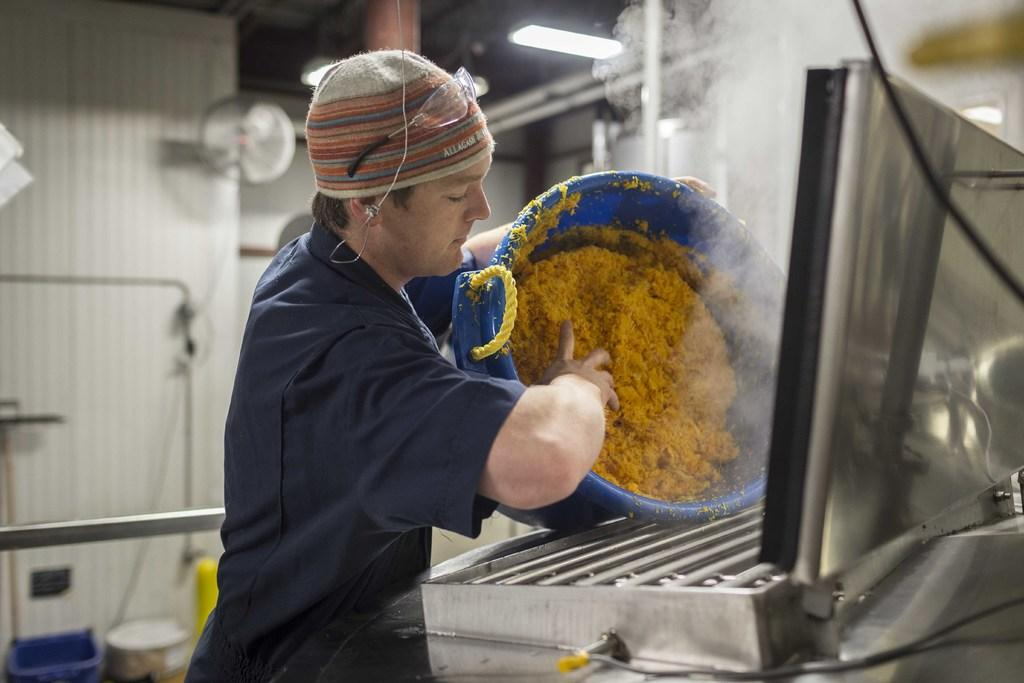Who is present in the image? There is a man in the image. What is the man doing in the image? The man is standing near a grill and taking items from a tube. What can be seen in the background of the image? There are walls and a light in the background of the image. How would you describe the background of the image? The background appears blurred. What type of coat is the man wearing in the image? The man is not wearing a coat in the image. Can you tell me what hospital the man is visiting in the image? There is no hospital present in the image; it features a man standing near a grill. 